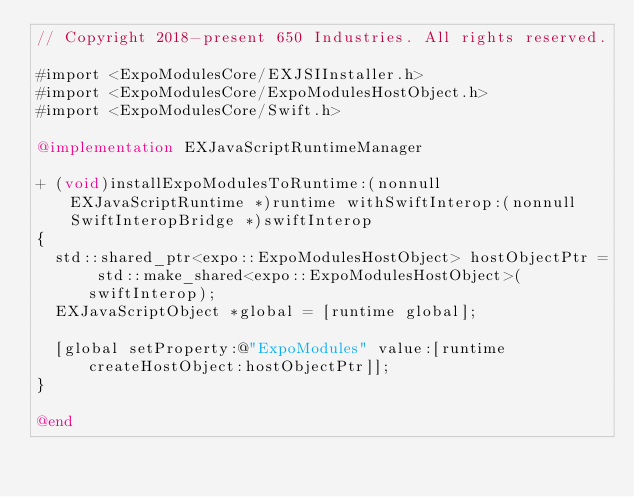<code> <loc_0><loc_0><loc_500><loc_500><_ObjectiveC_>// Copyright 2018-present 650 Industries. All rights reserved.

#import <ExpoModulesCore/EXJSIInstaller.h>
#import <ExpoModulesCore/ExpoModulesHostObject.h>
#import <ExpoModulesCore/Swift.h>

@implementation EXJavaScriptRuntimeManager

+ (void)installExpoModulesToRuntime:(nonnull EXJavaScriptRuntime *)runtime withSwiftInterop:(nonnull SwiftInteropBridge *)swiftInterop
{
  std::shared_ptr<expo::ExpoModulesHostObject> hostObjectPtr = std::make_shared<expo::ExpoModulesHostObject>(swiftInterop);
  EXJavaScriptObject *global = [runtime global];

  [global setProperty:@"ExpoModules" value:[runtime createHostObject:hostObjectPtr]];
}

@end
</code> 